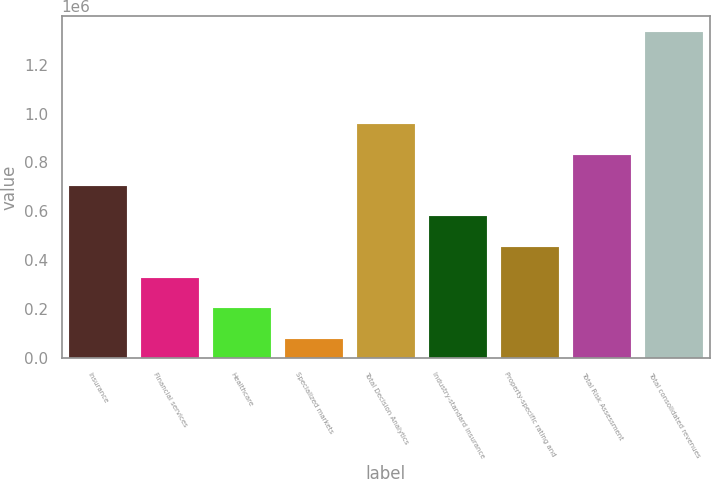Convert chart. <chart><loc_0><loc_0><loc_500><loc_500><bar_chart><fcel>Insurance<fcel>Financial services<fcel>Healthcare<fcel>Specialized markets<fcel>Total Decision Analytics<fcel>Industry-standard insurance<fcel>Property-specific rating and<fcel>Total Risk Assessment<fcel>Total consolidated revenues<nl><fcel>705340<fcel>329439<fcel>204139<fcel>78839<fcel>955940<fcel>580039<fcel>454739<fcel>830640<fcel>1.33184e+06<nl></chart> 